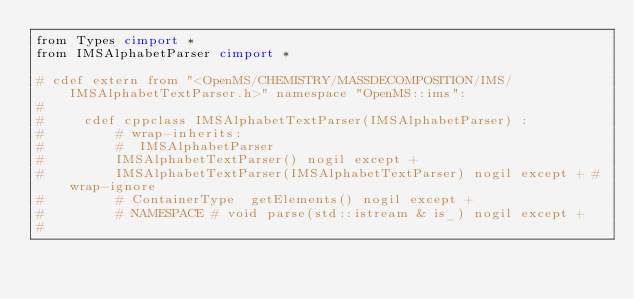Convert code to text. <code><loc_0><loc_0><loc_500><loc_500><_Cython_>from Types cimport *
from IMSAlphabetParser cimport *

# cdef extern from "<OpenMS/CHEMISTRY/MASSDECOMPOSITION/IMS/IMSAlphabetTextParser.h>" namespace "OpenMS::ims":
#     
#     cdef cppclass IMSAlphabetTextParser(IMSAlphabetParser) :
#         # wrap-inherits:
#         #  IMSAlphabetParser
#         IMSAlphabetTextParser() nogil except + 
#         IMSAlphabetTextParser(IMSAlphabetTextParser) nogil except + #wrap-ignore
#         # ContainerType  getElements() nogil except +
#         # NAMESPACE # void parse(std::istream & is_) nogil except +
# 
</code> 